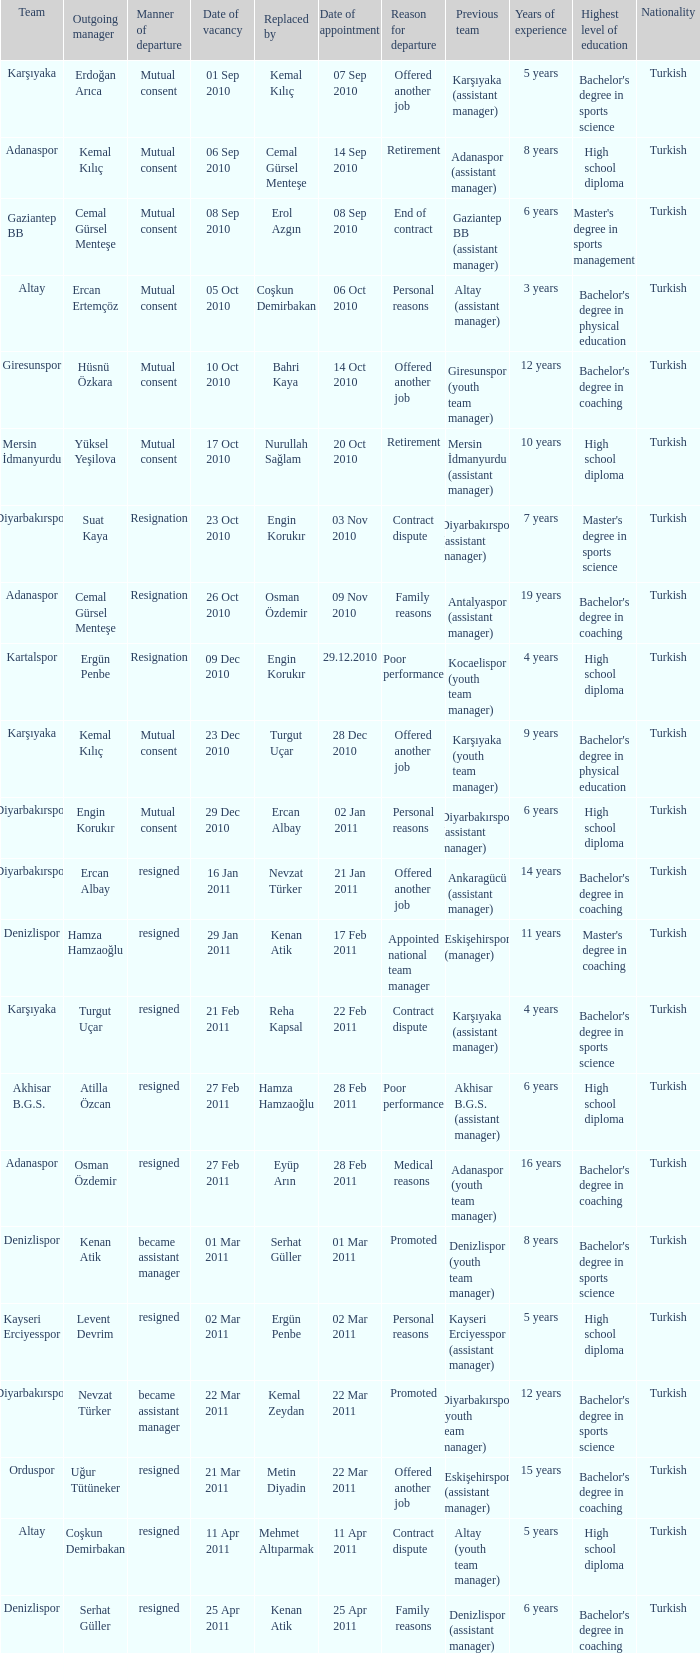When was the date of vacancy for the manager of Kartalspor?  09 Dec 2010. 